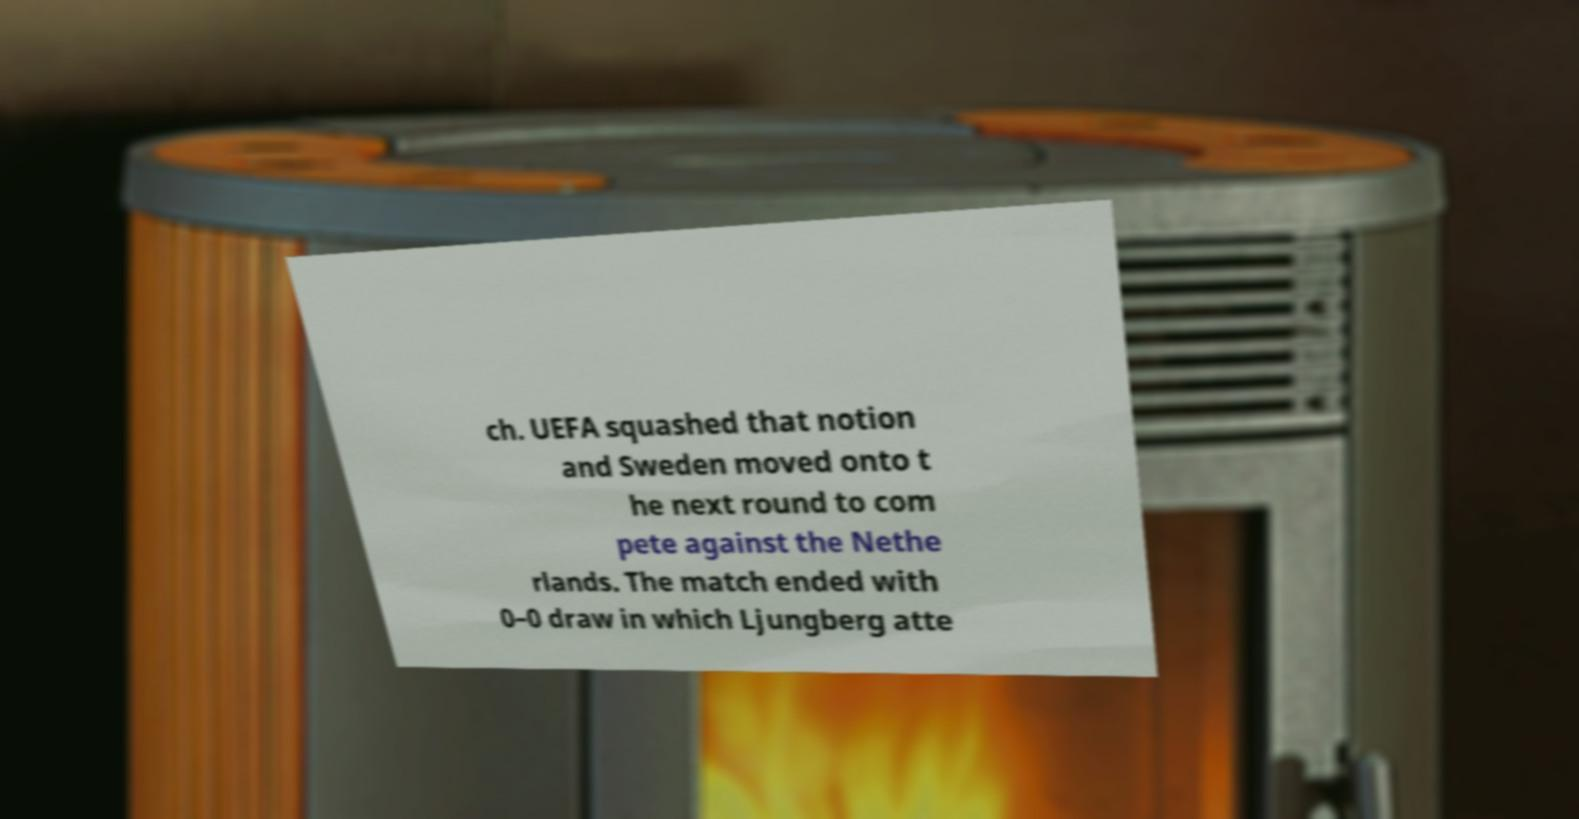Please identify and transcribe the text found in this image. ch. UEFA squashed that notion and Sweden moved onto t he next round to com pete against the Nethe rlands. The match ended with 0–0 draw in which Ljungberg atte 